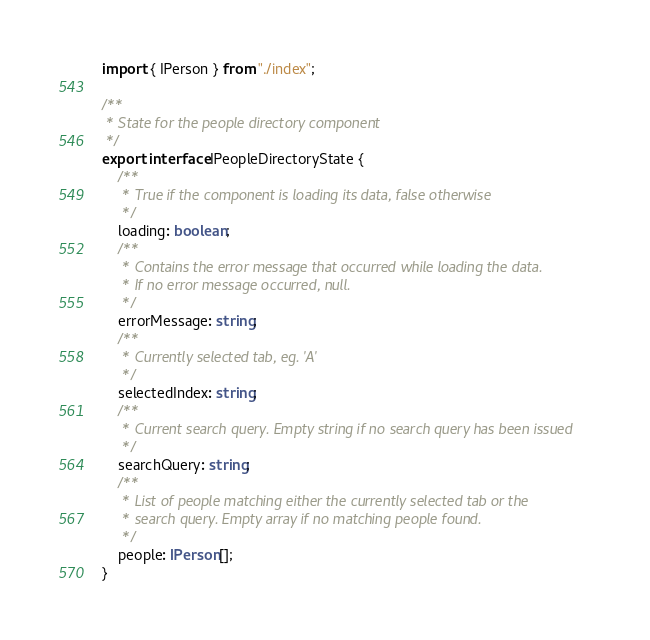Convert code to text. <code><loc_0><loc_0><loc_500><loc_500><_TypeScript_>import { IPerson } from "./index";

/**
 * State for the people directory component
 */
export interface IPeopleDirectoryState {
    /**
     * True if the component is loading its data, false otherwise
     */
    loading: boolean;
    /**
     * Contains the error message that occurred while loading the data.
     * If no error message occurred, null.
     */
    errorMessage: string;
    /**
     * Currently selected tab, eg. 'A'
     */
    selectedIndex: string;
    /**
     * Current search query. Empty string if no search query has been issued
     */
    searchQuery: string;
    /**
     * List of people matching either the currently selected tab or the
     * search query. Empty array if no matching people found.
     */
    people: IPerson[];
}</code> 